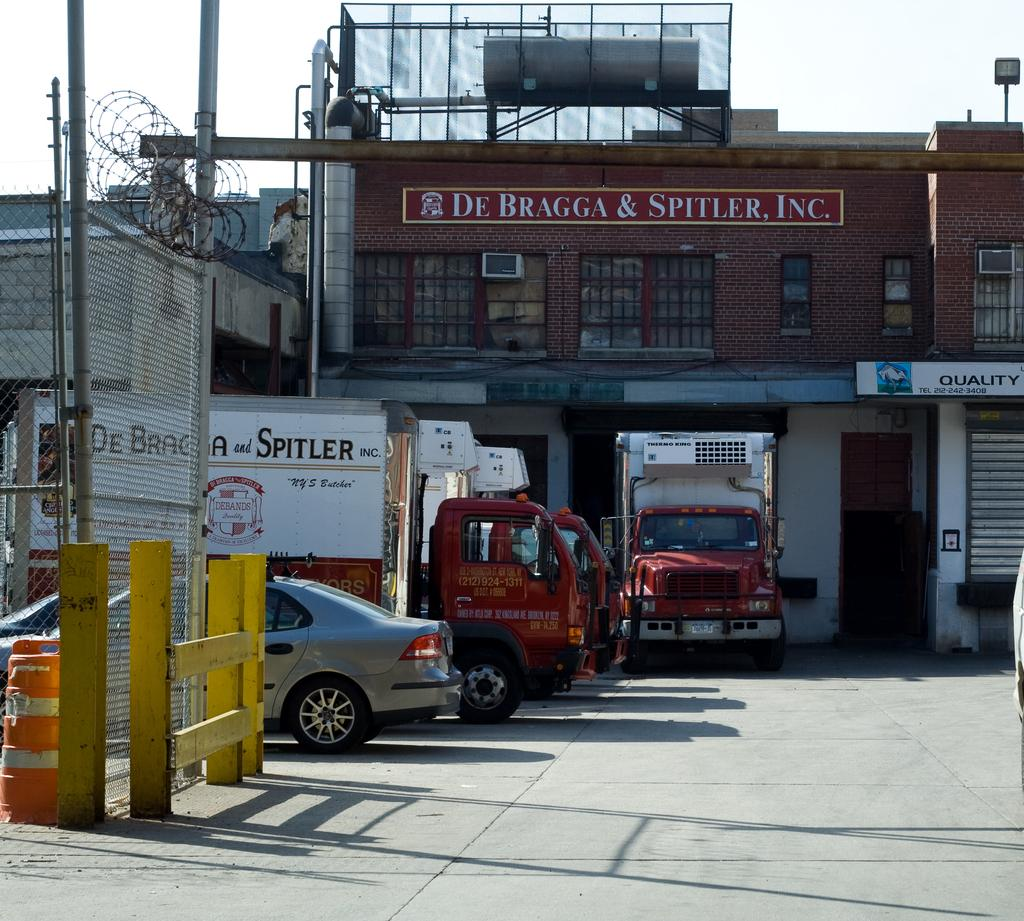<image>
Describe the image concisely. The butcher company De Bragga & Spitler, Inc. has their own delivery trucks. 